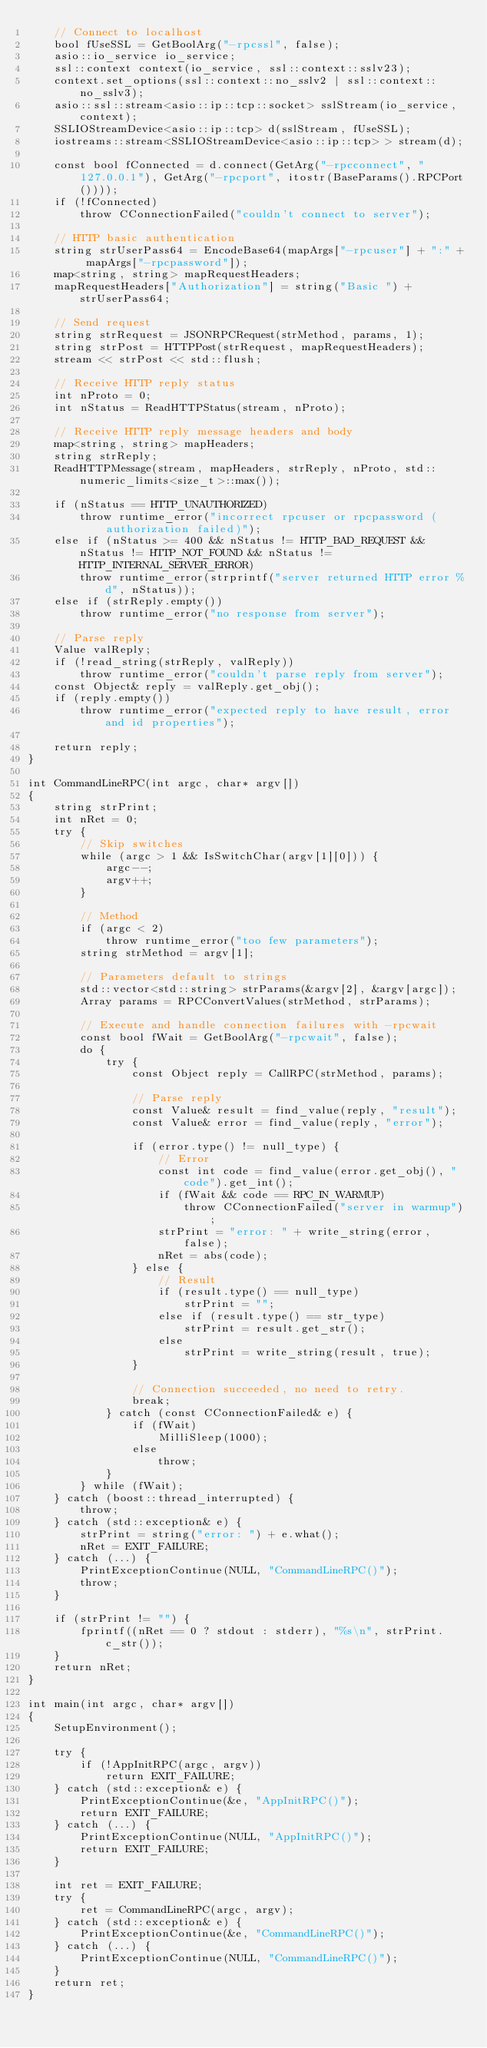Convert code to text. <code><loc_0><loc_0><loc_500><loc_500><_C++_>    // Connect to localhost
    bool fUseSSL = GetBoolArg("-rpcssl", false);
    asio::io_service io_service;
    ssl::context context(io_service, ssl::context::sslv23);
    context.set_options(ssl::context::no_sslv2 | ssl::context::no_sslv3);
    asio::ssl::stream<asio::ip::tcp::socket> sslStream(io_service, context);
    SSLIOStreamDevice<asio::ip::tcp> d(sslStream, fUseSSL);
    iostreams::stream<SSLIOStreamDevice<asio::ip::tcp> > stream(d);

    const bool fConnected = d.connect(GetArg("-rpcconnect", "127.0.0.1"), GetArg("-rpcport", itostr(BaseParams().RPCPort())));
    if (!fConnected)
        throw CConnectionFailed("couldn't connect to server");

    // HTTP basic authentication
    string strUserPass64 = EncodeBase64(mapArgs["-rpcuser"] + ":" + mapArgs["-rpcpassword"]);
    map<string, string> mapRequestHeaders;
    mapRequestHeaders["Authorization"] = string("Basic ") + strUserPass64;

    // Send request
    string strRequest = JSONRPCRequest(strMethod, params, 1);
    string strPost = HTTPPost(strRequest, mapRequestHeaders);
    stream << strPost << std::flush;

    // Receive HTTP reply status
    int nProto = 0;
    int nStatus = ReadHTTPStatus(stream, nProto);

    // Receive HTTP reply message headers and body
    map<string, string> mapHeaders;
    string strReply;
    ReadHTTPMessage(stream, mapHeaders, strReply, nProto, std::numeric_limits<size_t>::max());

    if (nStatus == HTTP_UNAUTHORIZED)
        throw runtime_error("incorrect rpcuser or rpcpassword (authorization failed)");
    else if (nStatus >= 400 && nStatus != HTTP_BAD_REQUEST && nStatus != HTTP_NOT_FOUND && nStatus != HTTP_INTERNAL_SERVER_ERROR)
        throw runtime_error(strprintf("server returned HTTP error %d", nStatus));
    else if (strReply.empty())
        throw runtime_error("no response from server");

    // Parse reply
    Value valReply;
    if (!read_string(strReply, valReply))
        throw runtime_error("couldn't parse reply from server");
    const Object& reply = valReply.get_obj();
    if (reply.empty())
        throw runtime_error("expected reply to have result, error and id properties");

    return reply;
}

int CommandLineRPC(int argc, char* argv[])
{
    string strPrint;
    int nRet = 0;
    try {
        // Skip switches
        while (argc > 1 && IsSwitchChar(argv[1][0])) {
            argc--;
            argv++;
        }

        // Method
        if (argc < 2)
            throw runtime_error("too few parameters");
        string strMethod = argv[1];

        // Parameters default to strings
        std::vector<std::string> strParams(&argv[2], &argv[argc]);
        Array params = RPCConvertValues(strMethod, strParams);

        // Execute and handle connection failures with -rpcwait
        const bool fWait = GetBoolArg("-rpcwait", false);
        do {
            try {
                const Object reply = CallRPC(strMethod, params);

                // Parse reply
                const Value& result = find_value(reply, "result");
                const Value& error = find_value(reply, "error");

                if (error.type() != null_type) {
                    // Error
                    const int code = find_value(error.get_obj(), "code").get_int();
                    if (fWait && code == RPC_IN_WARMUP)
                        throw CConnectionFailed("server in warmup");
                    strPrint = "error: " + write_string(error, false);
                    nRet = abs(code);
                } else {
                    // Result
                    if (result.type() == null_type)
                        strPrint = "";
                    else if (result.type() == str_type)
                        strPrint = result.get_str();
                    else
                        strPrint = write_string(result, true);
                }

                // Connection succeeded, no need to retry.
                break;
            } catch (const CConnectionFailed& e) {
                if (fWait)
                    MilliSleep(1000);
                else
                    throw;
            }
        } while (fWait);
    } catch (boost::thread_interrupted) {
        throw;
    } catch (std::exception& e) {
        strPrint = string("error: ") + e.what();
        nRet = EXIT_FAILURE;
    } catch (...) {
        PrintExceptionContinue(NULL, "CommandLineRPC()");
        throw;
    }

    if (strPrint != "") {
        fprintf((nRet == 0 ? stdout : stderr), "%s\n", strPrint.c_str());
    }
    return nRet;
}

int main(int argc, char* argv[])
{
    SetupEnvironment();

    try {
        if (!AppInitRPC(argc, argv))
            return EXIT_FAILURE;
    } catch (std::exception& e) {
        PrintExceptionContinue(&e, "AppInitRPC()");
        return EXIT_FAILURE;
    } catch (...) {
        PrintExceptionContinue(NULL, "AppInitRPC()");
        return EXIT_FAILURE;
    }

    int ret = EXIT_FAILURE;
    try {
        ret = CommandLineRPC(argc, argv);
    } catch (std::exception& e) {
        PrintExceptionContinue(&e, "CommandLineRPC()");
    } catch (...) {
        PrintExceptionContinue(NULL, "CommandLineRPC()");
    }
    return ret;
}
</code> 